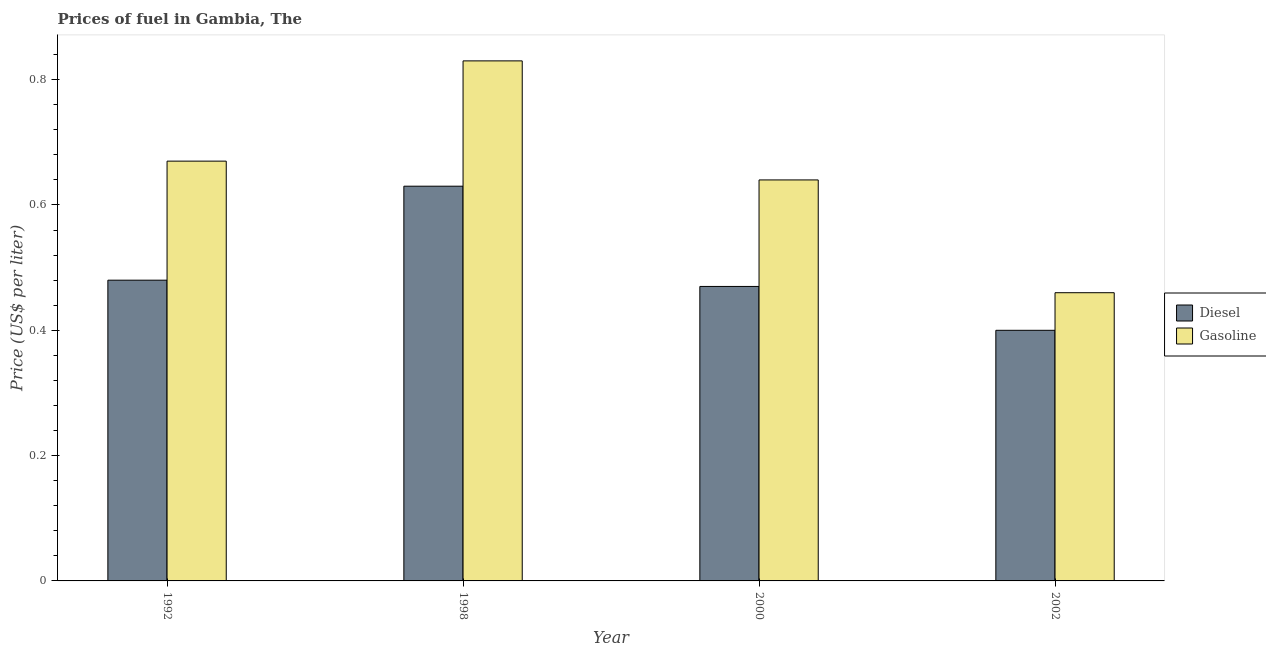How many different coloured bars are there?
Keep it short and to the point. 2. How many groups of bars are there?
Your answer should be compact. 4. Are the number of bars per tick equal to the number of legend labels?
Ensure brevity in your answer.  Yes. How many bars are there on the 4th tick from the left?
Ensure brevity in your answer.  2. In how many cases, is the number of bars for a given year not equal to the number of legend labels?
Your answer should be compact. 0. What is the diesel price in 1998?
Your response must be concise. 0.63. Across all years, what is the maximum gasoline price?
Offer a very short reply. 0.83. Across all years, what is the minimum gasoline price?
Ensure brevity in your answer.  0.46. In which year was the gasoline price maximum?
Give a very brief answer. 1998. What is the difference between the gasoline price in 1992 and that in 1998?
Provide a succinct answer. -0.16. What is the difference between the diesel price in 2000 and the gasoline price in 1992?
Offer a terse response. -0.01. What is the average diesel price per year?
Give a very brief answer. 0.49. What is the ratio of the diesel price in 2000 to that in 2002?
Ensure brevity in your answer.  1.17. What is the difference between the highest and the second highest diesel price?
Ensure brevity in your answer.  0.15. What is the difference between the highest and the lowest gasoline price?
Offer a very short reply. 0.37. What does the 1st bar from the left in 1992 represents?
Your answer should be very brief. Diesel. What does the 2nd bar from the right in 1998 represents?
Give a very brief answer. Diesel. How many bars are there?
Offer a very short reply. 8. Are all the bars in the graph horizontal?
Offer a terse response. No. What is the difference between two consecutive major ticks on the Y-axis?
Your response must be concise. 0.2. Are the values on the major ticks of Y-axis written in scientific E-notation?
Your answer should be very brief. No. Does the graph contain grids?
Your response must be concise. No. Where does the legend appear in the graph?
Provide a succinct answer. Center right. How many legend labels are there?
Provide a succinct answer. 2. How are the legend labels stacked?
Your answer should be very brief. Vertical. What is the title of the graph?
Ensure brevity in your answer.  Prices of fuel in Gambia, The. What is the label or title of the X-axis?
Offer a terse response. Year. What is the label or title of the Y-axis?
Provide a succinct answer. Price (US$ per liter). What is the Price (US$ per liter) of Diesel in 1992?
Give a very brief answer. 0.48. What is the Price (US$ per liter) in Gasoline in 1992?
Provide a short and direct response. 0.67. What is the Price (US$ per liter) in Diesel in 1998?
Your response must be concise. 0.63. What is the Price (US$ per liter) of Gasoline in 1998?
Keep it short and to the point. 0.83. What is the Price (US$ per liter) in Diesel in 2000?
Offer a very short reply. 0.47. What is the Price (US$ per liter) of Gasoline in 2000?
Provide a succinct answer. 0.64. What is the Price (US$ per liter) in Gasoline in 2002?
Make the answer very short. 0.46. Across all years, what is the maximum Price (US$ per liter) of Diesel?
Offer a very short reply. 0.63. Across all years, what is the maximum Price (US$ per liter) in Gasoline?
Provide a short and direct response. 0.83. Across all years, what is the minimum Price (US$ per liter) in Diesel?
Keep it short and to the point. 0.4. Across all years, what is the minimum Price (US$ per liter) of Gasoline?
Keep it short and to the point. 0.46. What is the total Price (US$ per liter) of Diesel in the graph?
Provide a succinct answer. 1.98. What is the total Price (US$ per liter) in Gasoline in the graph?
Your answer should be very brief. 2.6. What is the difference between the Price (US$ per liter) in Gasoline in 1992 and that in 1998?
Keep it short and to the point. -0.16. What is the difference between the Price (US$ per liter) of Gasoline in 1992 and that in 2002?
Your answer should be very brief. 0.21. What is the difference between the Price (US$ per liter) of Diesel in 1998 and that in 2000?
Provide a short and direct response. 0.16. What is the difference between the Price (US$ per liter) of Gasoline in 1998 and that in 2000?
Provide a succinct answer. 0.19. What is the difference between the Price (US$ per liter) in Diesel in 1998 and that in 2002?
Your answer should be very brief. 0.23. What is the difference between the Price (US$ per liter) in Gasoline in 1998 and that in 2002?
Your response must be concise. 0.37. What is the difference between the Price (US$ per liter) in Diesel in 2000 and that in 2002?
Keep it short and to the point. 0.07. What is the difference between the Price (US$ per liter) of Gasoline in 2000 and that in 2002?
Your answer should be compact. 0.18. What is the difference between the Price (US$ per liter) in Diesel in 1992 and the Price (US$ per liter) in Gasoline in 1998?
Keep it short and to the point. -0.35. What is the difference between the Price (US$ per liter) of Diesel in 1992 and the Price (US$ per liter) of Gasoline in 2000?
Offer a terse response. -0.16. What is the difference between the Price (US$ per liter) in Diesel in 1998 and the Price (US$ per liter) in Gasoline in 2000?
Make the answer very short. -0.01. What is the difference between the Price (US$ per liter) of Diesel in 1998 and the Price (US$ per liter) of Gasoline in 2002?
Your response must be concise. 0.17. What is the average Price (US$ per liter) in Diesel per year?
Offer a terse response. 0.49. What is the average Price (US$ per liter) of Gasoline per year?
Offer a very short reply. 0.65. In the year 1992, what is the difference between the Price (US$ per liter) of Diesel and Price (US$ per liter) of Gasoline?
Your response must be concise. -0.19. In the year 1998, what is the difference between the Price (US$ per liter) in Diesel and Price (US$ per liter) in Gasoline?
Provide a succinct answer. -0.2. In the year 2000, what is the difference between the Price (US$ per liter) of Diesel and Price (US$ per liter) of Gasoline?
Keep it short and to the point. -0.17. In the year 2002, what is the difference between the Price (US$ per liter) in Diesel and Price (US$ per liter) in Gasoline?
Your response must be concise. -0.06. What is the ratio of the Price (US$ per liter) of Diesel in 1992 to that in 1998?
Your answer should be compact. 0.76. What is the ratio of the Price (US$ per liter) in Gasoline in 1992 to that in 1998?
Keep it short and to the point. 0.81. What is the ratio of the Price (US$ per liter) of Diesel in 1992 to that in 2000?
Ensure brevity in your answer.  1.02. What is the ratio of the Price (US$ per liter) of Gasoline in 1992 to that in 2000?
Your answer should be very brief. 1.05. What is the ratio of the Price (US$ per liter) of Gasoline in 1992 to that in 2002?
Keep it short and to the point. 1.46. What is the ratio of the Price (US$ per liter) in Diesel in 1998 to that in 2000?
Your answer should be compact. 1.34. What is the ratio of the Price (US$ per liter) in Gasoline in 1998 to that in 2000?
Your answer should be compact. 1.3. What is the ratio of the Price (US$ per liter) of Diesel in 1998 to that in 2002?
Offer a terse response. 1.57. What is the ratio of the Price (US$ per liter) in Gasoline in 1998 to that in 2002?
Make the answer very short. 1.8. What is the ratio of the Price (US$ per liter) of Diesel in 2000 to that in 2002?
Make the answer very short. 1.18. What is the ratio of the Price (US$ per liter) in Gasoline in 2000 to that in 2002?
Make the answer very short. 1.39. What is the difference between the highest and the second highest Price (US$ per liter) of Diesel?
Keep it short and to the point. 0.15. What is the difference between the highest and the second highest Price (US$ per liter) in Gasoline?
Your answer should be very brief. 0.16. What is the difference between the highest and the lowest Price (US$ per liter) in Diesel?
Your answer should be very brief. 0.23. What is the difference between the highest and the lowest Price (US$ per liter) in Gasoline?
Keep it short and to the point. 0.37. 